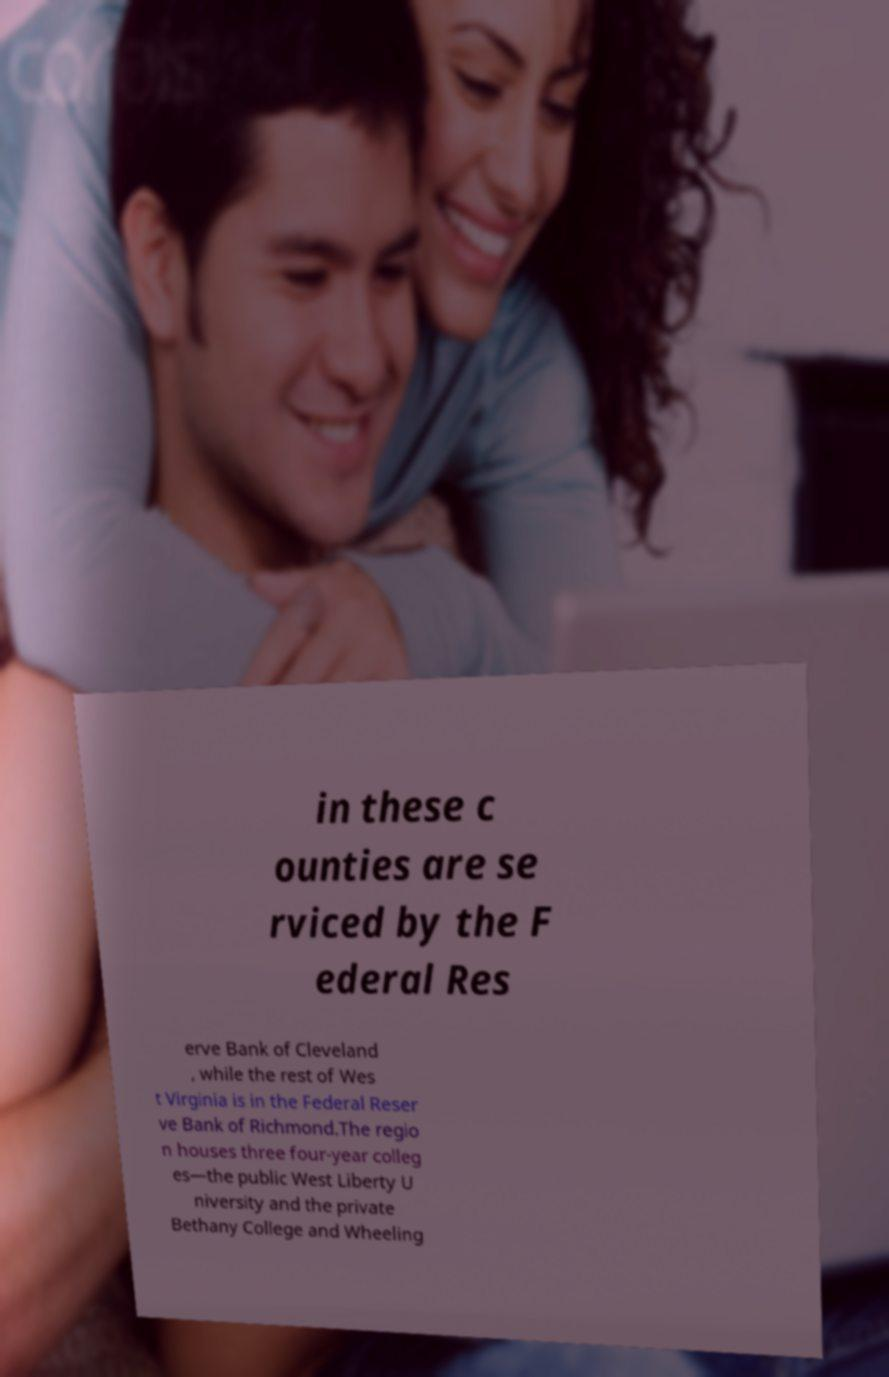Can you accurately transcribe the text from the provided image for me? in these c ounties are se rviced by the F ederal Res erve Bank of Cleveland , while the rest of Wes t Virginia is in the Federal Reser ve Bank of Richmond.The regio n houses three four-year colleg es—the public West Liberty U niversity and the private Bethany College and Wheeling 